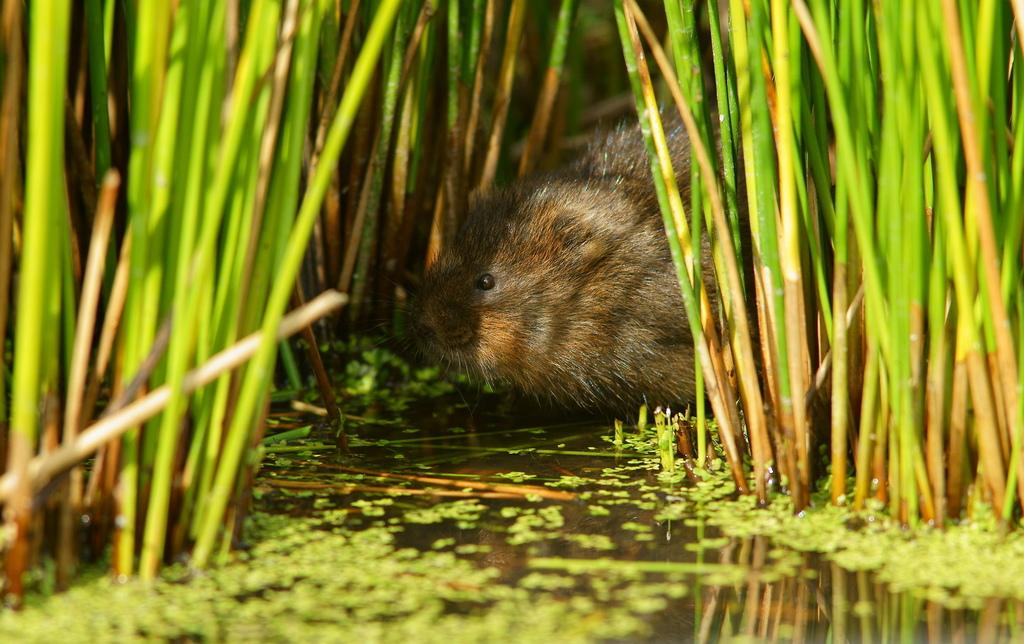What is in the water in the image? There is an animal in the water in the image. What type of vegetation can be seen in the image? There are plants in the image. Can you describe any specific details about the plants? There are leaves visible in the image. What type of tax is being discussed in the image? There is no discussion of tax in the image; it features an animal in the water and plants with leaves. 